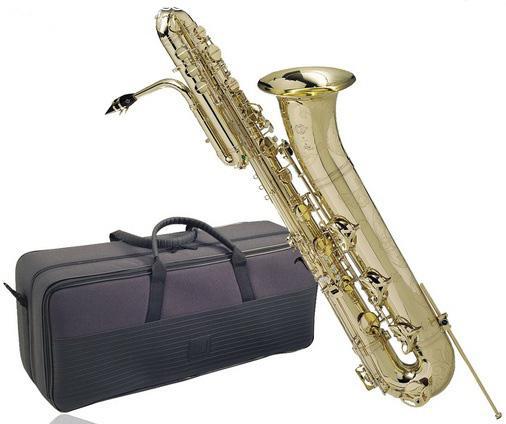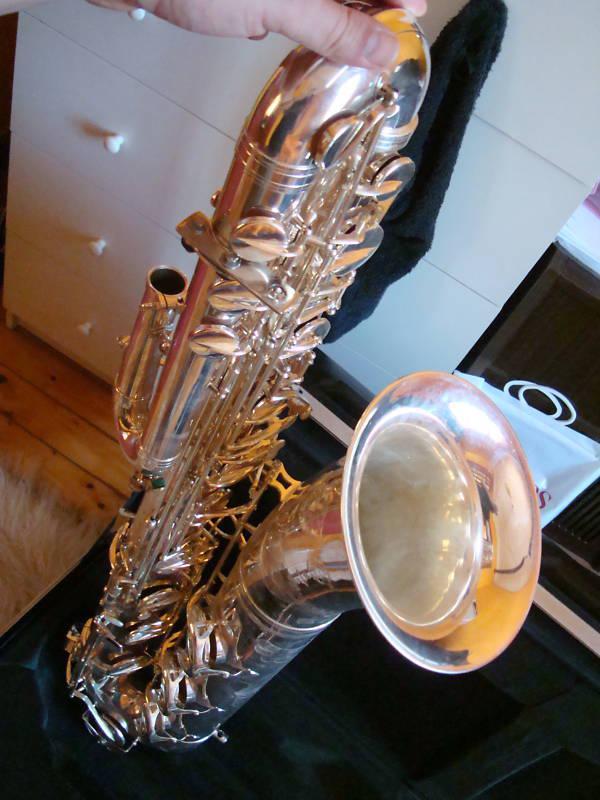The first image is the image on the left, the second image is the image on the right. Given the left and right images, does the statement "At least one mouthpiece is black." hold true? Answer yes or no. Yes. The first image is the image on the left, the second image is the image on the right. Considering the images on both sides, is "The left image features a saxophone on a stand tilting rightward." valid? Answer yes or no. No. 